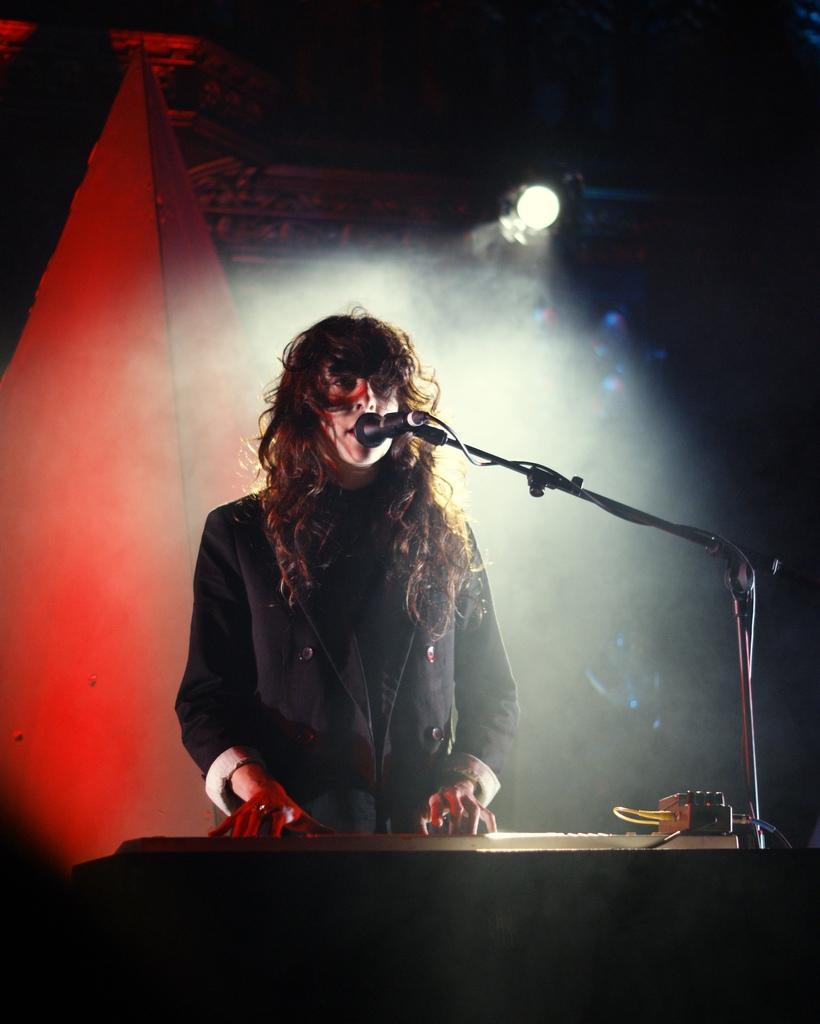Can you describe this image briefly? In this image we can see a person standing, we can also see a microphone placed on a stand. At the bottom of the image we can see a device with cables placed on the surface. In the background, we can see the light. 